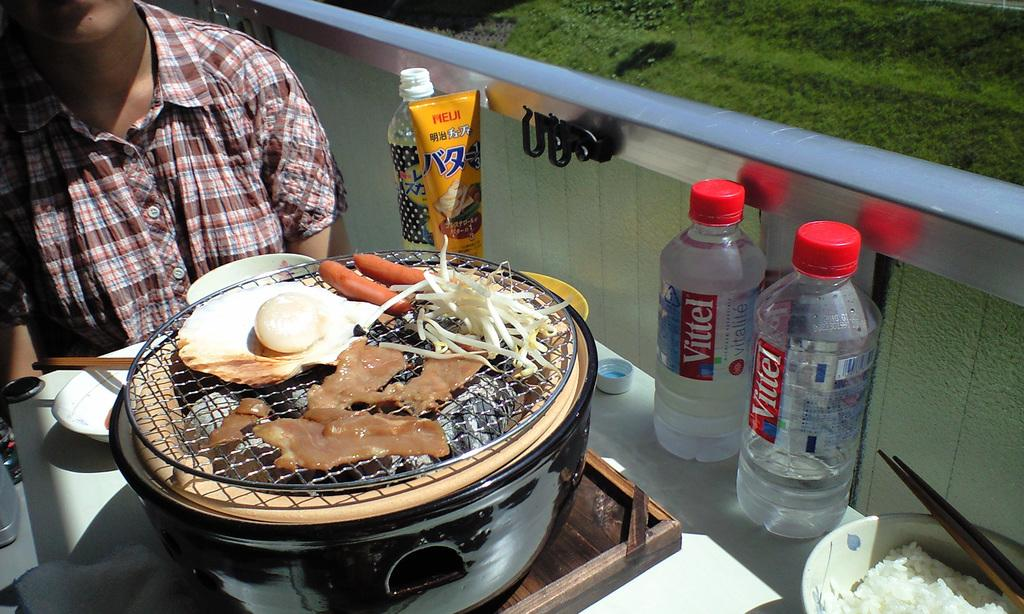<image>
Relay a brief, clear account of the picture shown. a bottle with a red tag that says vittel 